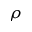<formula> <loc_0><loc_0><loc_500><loc_500>\rho</formula> 